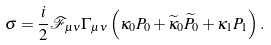Convert formula to latex. <formula><loc_0><loc_0><loc_500><loc_500>\sigma = \frac { i } { 2 } \mathcal { F } _ { \mu \nu } \Gamma _ { \mu \nu } \left ( \kappa _ { 0 } P _ { 0 } + \widetilde { \kappa } _ { 0 } \widetilde { P } _ { 0 } + \kappa _ { 1 } P _ { 1 } \right ) .</formula> 